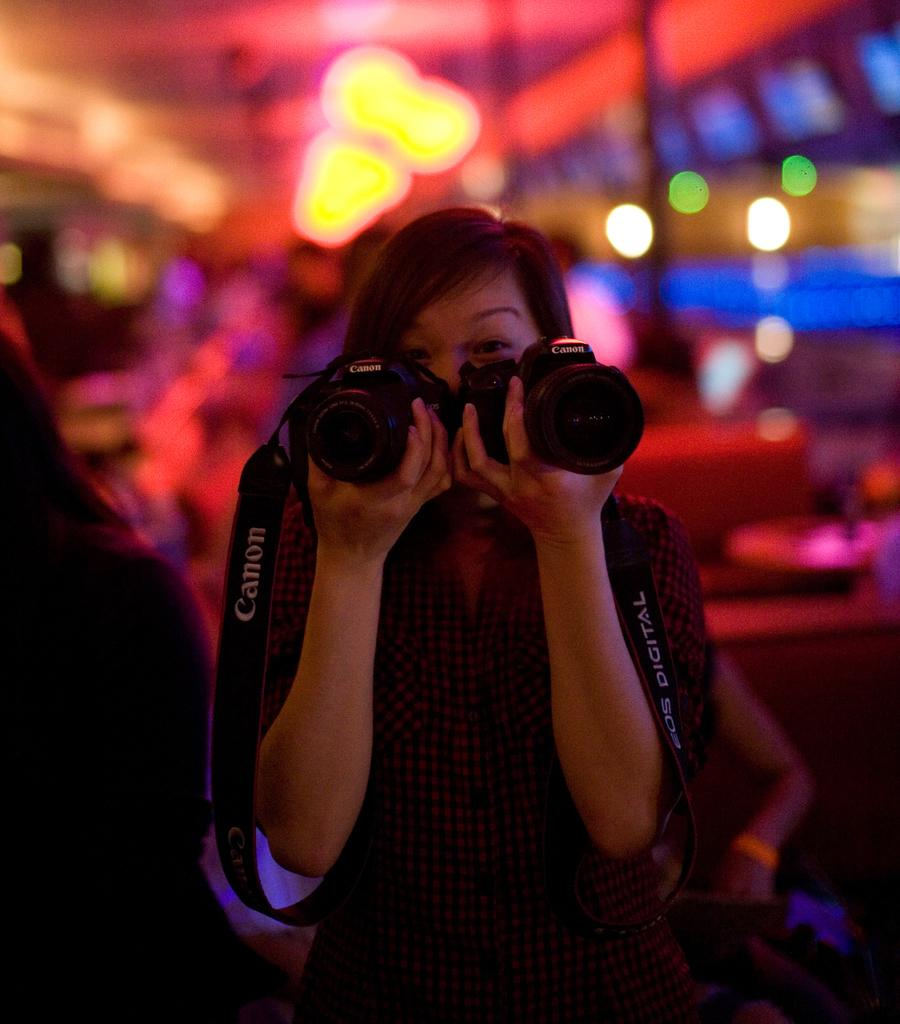Who is the main subject in the image? There is a woman in the image. What is the woman holding in her hands? The woman is holding two cameras in her hands. What can be seen in the background of the image? There are lights in the background of the image. What type of jam is the woman spreading on the gold angle in the image? There is no jam, gold, or angle present in the image. 